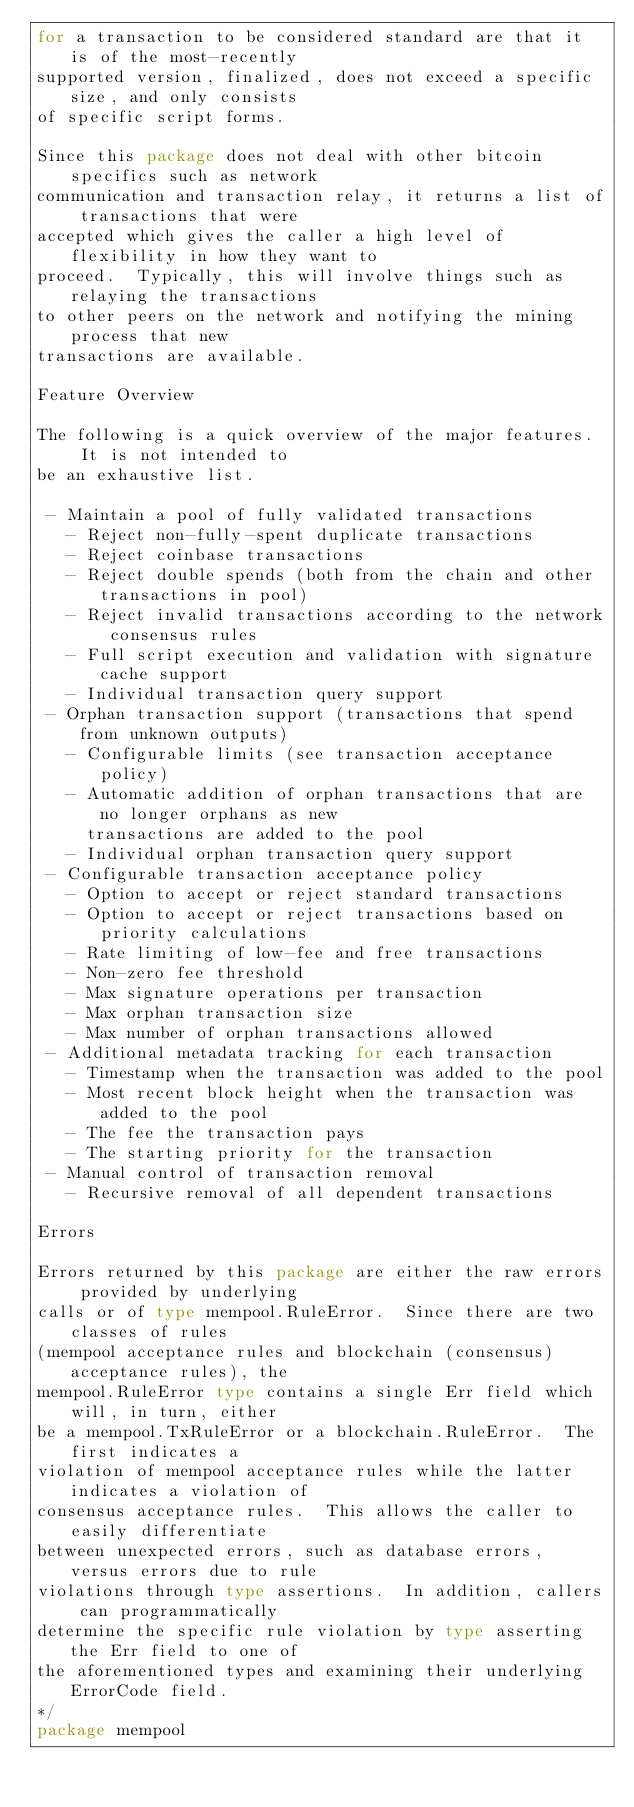Convert code to text. <code><loc_0><loc_0><loc_500><loc_500><_Go_>for a transaction to be considered standard are that it is of the most-recently
supported version, finalized, does not exceed a specific size, and only consists
of specific script forms.

Since this package does not deal with other bitcoin specifics such as network
communication and transaction relay, it returns a list of transactions that were
accepted which gives the caller a high level of flexibility in how they want to
proceed.  Typically, this will involve things such as relaying the transactions
to other peers on the network and notifying the mining process that new
transactions are available.

Feature Overview

The following is a quick overview of the major features.  It is not intended to
be an exhaustive list.

 - Maintain a pool of fully validated transactions
   - Reject non-fully-spent duplicate transactions
   - Reject coinbase transactions
   - Reject double spends (both from the chain and other transactions in pool)
   - Reject invalid transactions according to the network consensus rules
   - Full script execution and validation with signature cache support
   - Individual transaction query support
 - Orphan transaction support (transactions that spend from unknown outputs)
   - Configurable limits (see transaction acceptance policy)
   - Automatic addition of orphan transactions that are no longer orphans as new
     transactions are added to the pool
   - Individual orphan transaction query support
 - Configurable transaction acceptance policy
   - Option to accept or reject standard transactions
   - Option to accept or reject transactions based on priority calculations
   - Rate limiting of low-fee and free transactions
   - Non-zero fee threshold
   - Max signature operations per transaction
   - Max orphan transaction size
   - Max number of orphan transactions allowed
 - Additional metadata tracking for each transaction
   - Timestamp when the transaction was added to the pool
   - Most recent block height when the transaction was added to the pool
   - The fee the transaction pays
   - The starting priority for the transaction
 - Manual control of transaction removal
   - Recursive removal of all dependent transactions

Errors

Errors returned by this package are either the raw errors provided by underlying
calls or of type mempool.RuleError.  Since there are two classes of rules
(mempool acceptance rules and blockchain (consensus) acceptance rules), the
mempool.RuleError type contains a single Err field which will, in turn, either
be a mempool.TxRuleError or a blockchain.RuleError.  The first indicates a
violation of mempool acceptance rules while the latter indicates a violation of
consensus acceptance rules.  This allows the caller to easily differentiate
between unexpected errors, such as database errors, versus errors due to rule
violations through type assertions.  In addition, callers can programmatically
determine the specific rule violation by type asserting the Err field to one of
the aforementioned types and examining their underlying ErrorCode field.
*/
package mempool
</code> 